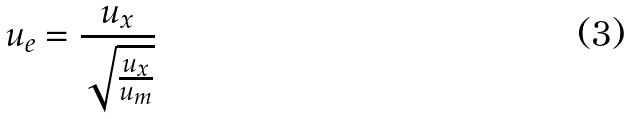<formula> <loc_0><loc_0><loc_500><loc_500>u _ { e } = \frac { u _ { x } } { \sqrt { \frac { u _ { x } } { u _ { m } } } }</formula> 